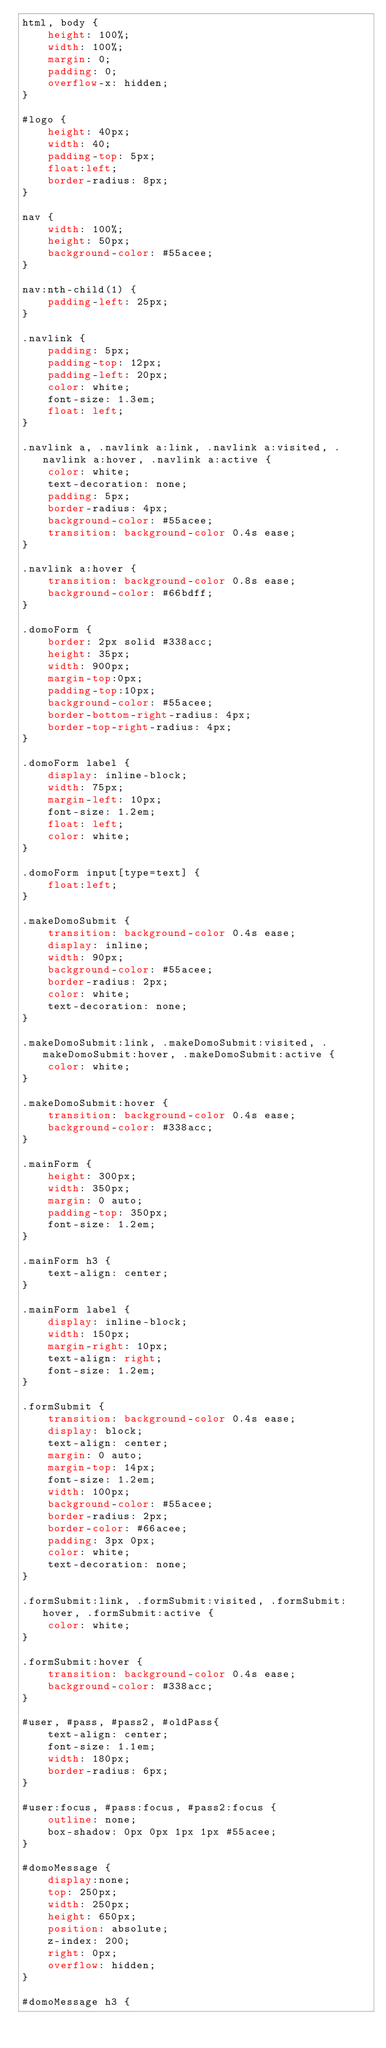<code> <loc_0><loc_0><loc_500><loc_500><_CSS_>html, body {
    height: 100%;
    width: 100%;
    margin: 0;
    padding: 0;
    overflow-x: hidden;
}

#logo {
    height: 40px;
    width: 40;
    padding-top: 5px;
    float:left;
    border-radius: 8px;
}

nav {
    width: 100%;
    height: 50px;
    background-color: #55acee;
}

nav:nth-child(1) {
    padding-left: 25px;
}

.navlink {
    padding: 5px;
    padding-top: 12px;
    padding-left: 20px;
    color: white;
    font-size: 1.3em;
    float: left;
}

.navlink a, .navlink a:link, .navlink a:visited, .navlink a:hover, .navlink a:active {
    color: white;
    text-decoration: none;
    padding: 5px;
    border-radius: 4px;
    background-color: #55acee;
    transition: background-color 0.4s ease;
}

.navlink a:hover {
    transition: background-color 0.8s ease;
    background-color: #66bdff;
}

.domoForm {
    border: 2px solid #338acc;
    height: 35px;
    width: 900px;
    margin-top:0px;
    padding-top:10px;
    background-color: #55acee;
    border-bottom-right-radius: 4px;
    border-top-right-radius: 4px;
}

.domoForm label {
    display: inline-block;
    width: 75px;
    margin-left: 10px;
    font-size: 1.2em;
    float: left;
    color: white;
}

.domoForm input[type=text] {
    float:left;
}

.makeDomoSubmit {
    transition: background-color 0.4s ease;
    display: inline;
    width: 90px;
    background-color: #55acee;
    border-radius: 2px;
    color: white;
    text-decoration: none;
}

.makeDomoSubmit:link, .makeDomoSubmit:visited, .makeDomoSubmit:hover, .makeDomoSubmit:active {
    color: white;
}

.makeDomoSubmit:hover {
    transition: background-color 0.4s ease;
    background-color: #338acc;
}

.mainForm {
    height: 300px;
    width: 350px;
    margin: 0 auto;
    padding-top: 350px;
    font-size: 1.2em;
}

.mainForm h3 {
    text-align: center;
}

.mainForm label {
    display: inline-block;
    width: 150px;
    margin-right: 10px;
    text-align: right;
    font-size: 1.2em;
}

.formSubmit {
    transition: background-color 0.4s ease;
    display: block;
    text-align: center;
    margin: 0 auto;
    margin-top: 14px;
    font-size: 1.2em;
    width: 100px;
    background-color: #55acee;
    border-radius: 2px;
    border-color: #66acee;
    padding: 3px 0px;
    color: white;
    text-decoration: none;
}

.formSubmit:link, .formSubmit:visited, .formSubmit:hover, .formSubmit:active {
    color: white;
}

.formSubmit:hover {
    transition: background-color 0.4s ease;
    background-color: #338acc;
}

#user, #pass, #pass2, #oldPass{
    text-align: center;
    font-size: 1.1em;
    width: 180px;
    border-radius: 6px;
}

#user:focus, #pass:focus, #pass2:focus {
    outline: none;
    box-shadow: 0px 0px 1px 1px #55acee;
}

#domoMessage {
    display:none;
    top: 250px;
    width: 250px;
    height: 650px;
    position: absolute;
    z-index: 200;
    right: 0px;
    overflow: hidden;
}

#domoMessage h3 {</code> 